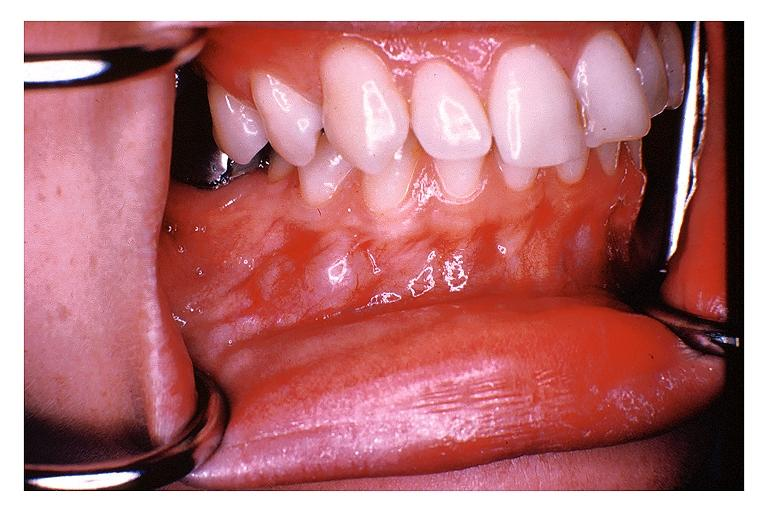does chancre show traumatic neuroma?
Answer the question using a single word or phrase. No 